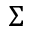<formula> <loc_0><loc_0><loc_500><loc_500>\Sigma</formula> 